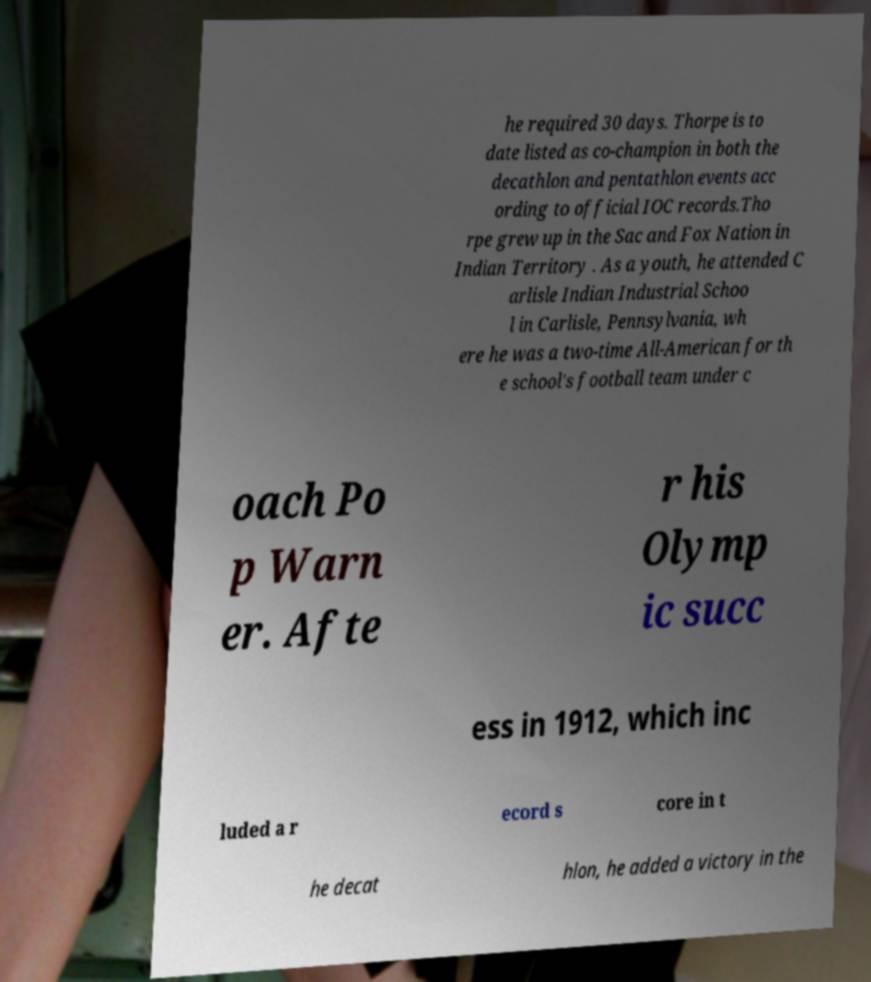Please read and relay the text visible in this image. What does it say? he required 30 days. Thorpe is to date listed as co-champion in both the decathlon and pentathlon events acc ording to official IOC records.Tho rpe grew up in the Sac and Fox Nation in Indian Territory . As a youth, he attended C arlisle Indian Industrial Schoo l in Carlisle, Pennsylvania, wh ere he was a two-time All-American for th e school's football team under c oach Po p Warn er. Afte r his Olymp ic succ ess in 1912, which inc luded a r ecord s core in t he decat hlon, he added a victory in the 